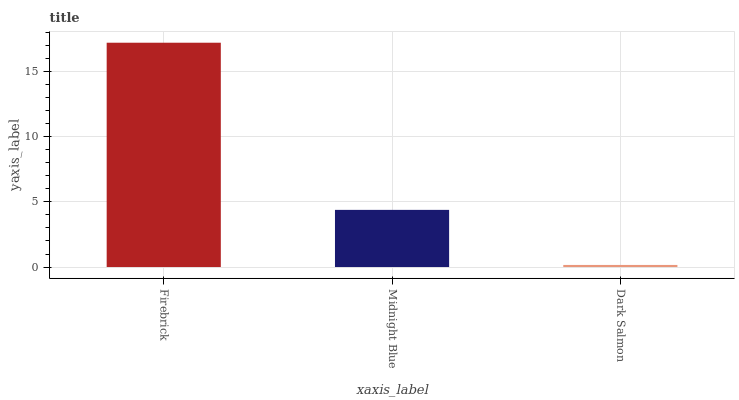Is Dark Salmon the minimum?
Answer yes or no. Yes. Is Firebrick the maximum?
Answer yes or no. Yes. Is Midnight Blue the minimum?
Answer yes or no. No. Is Midnight Blue the maximum?
Answer yes or no. No. Is Firebrick greater than Midnight Blue?
Answer yes or no. Yes. Is Midnight Blue less than Firebrick?
Answer yes or no. Yes. Is Midnight Blue greater than Firebrick?
Answer yes or no. No. Is Firebrick less than Midnight Blue?
Answer yes or no. No. Is Midnight Blue the high median?
Answer yes or no. Yes. Is Midnight Blue the low median?
Answer yes or no. Yes. Is Firebrick the high median?
Answer yes or no. No. Is Dark Salmon the low median?
Answer yes or no. No. 